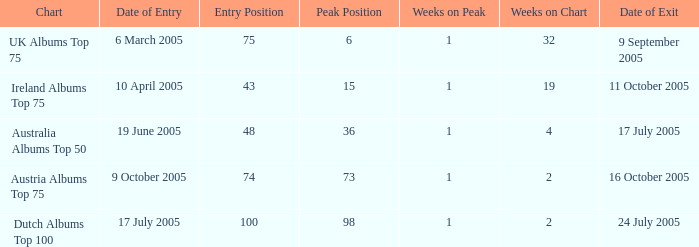What was the total number of weeks on peak for the Ireland Albums Top 75 chart? 1.0. 